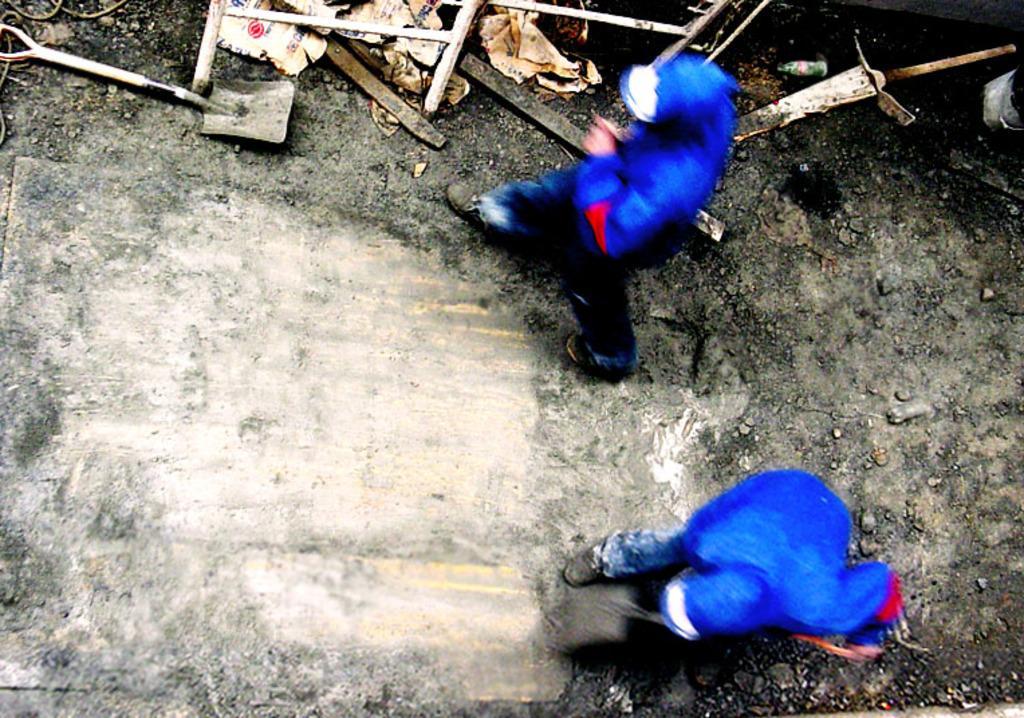Describe this image in one or two sentences. In the center of the image there are two persons wearing blue color jacket. At the bottom of the image there is road. 